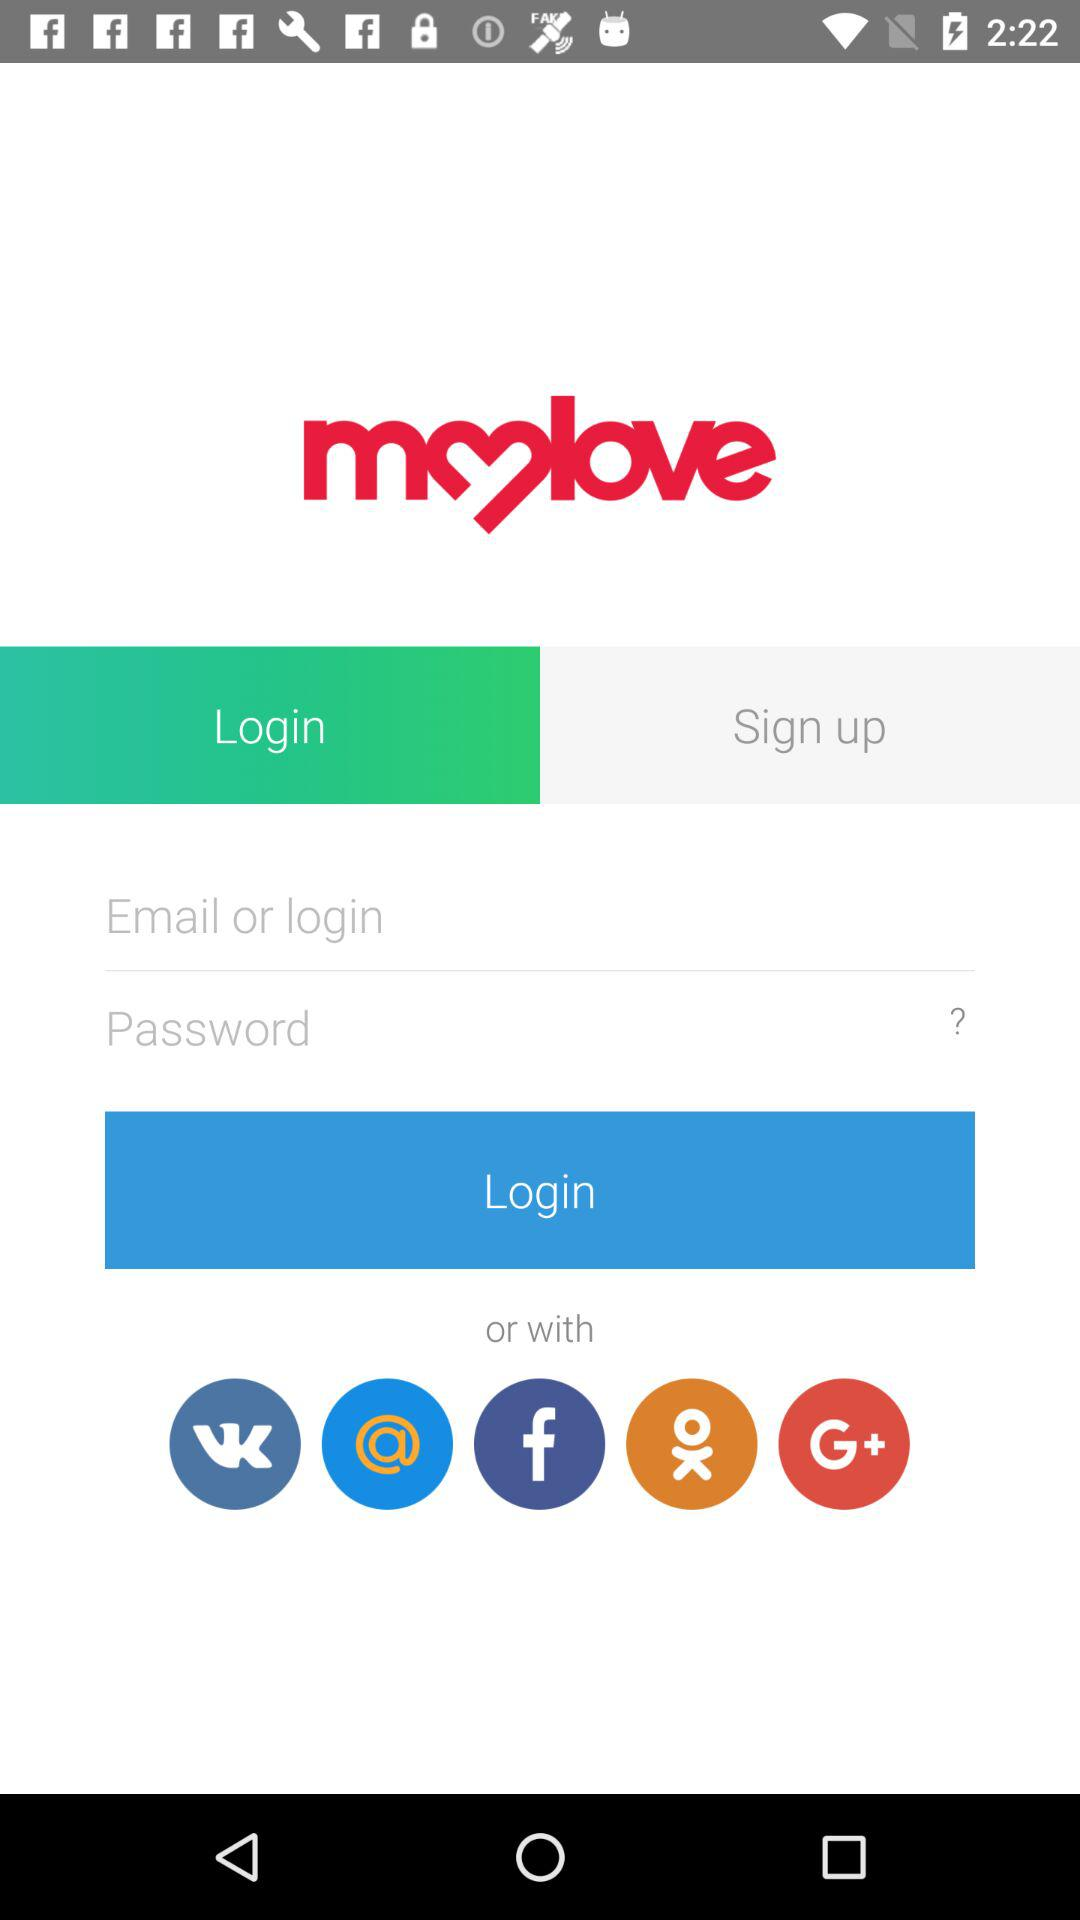What are the requirements for the password?
When the provided information is insufficient, respond with <no answer>. <no answer> 